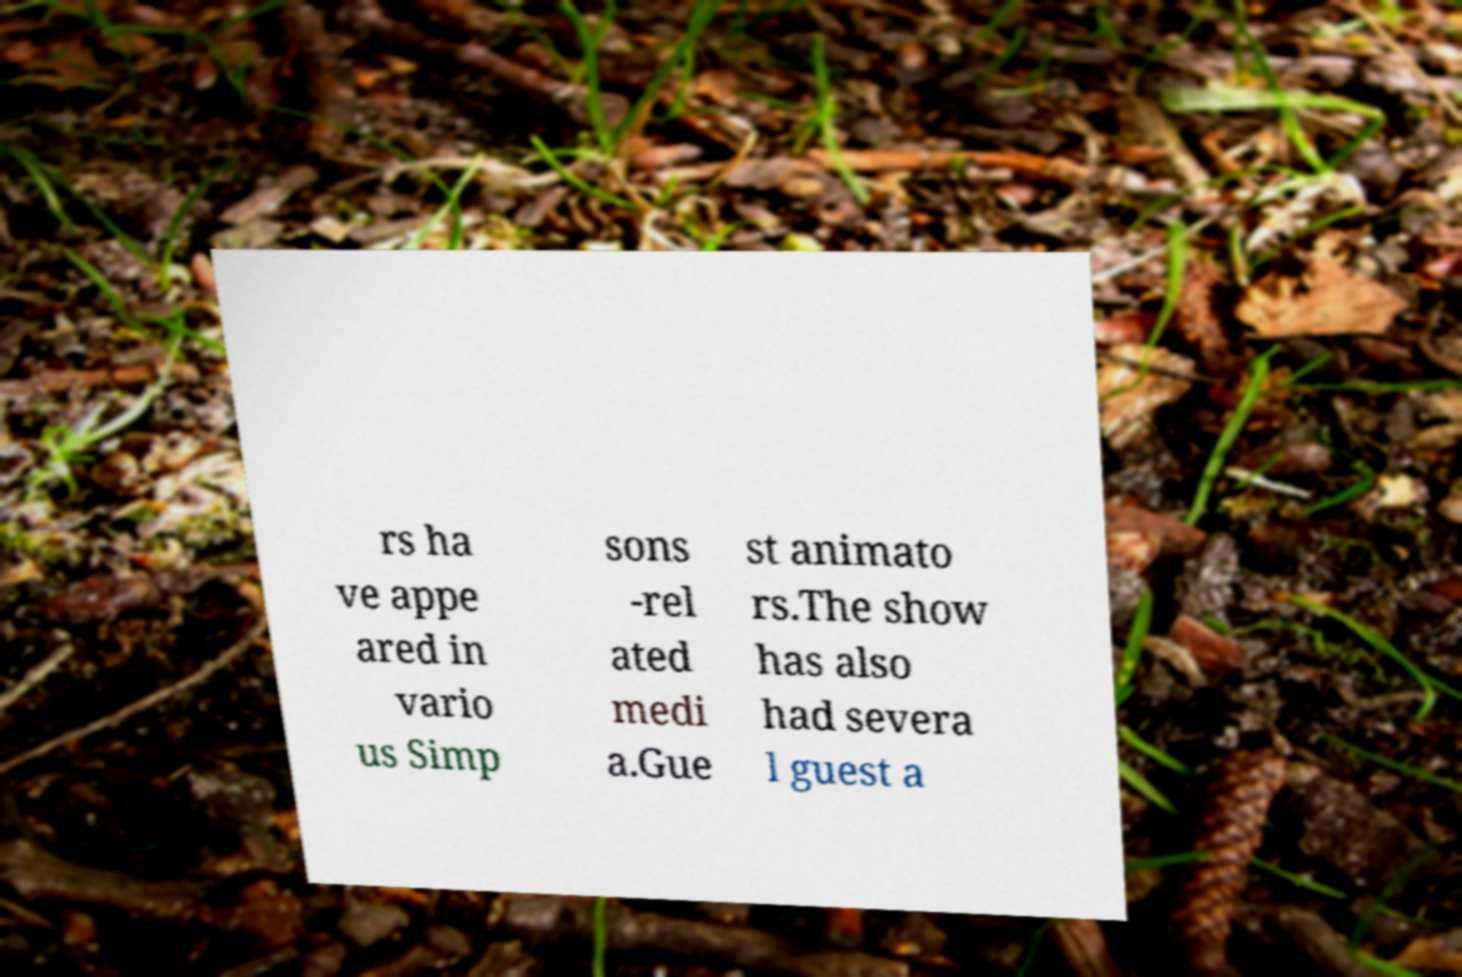What messages or text are displayed in this image? I need them in a readable, typed format. rs ha ve appe ared in vario us Simp sons -rel ated medi a.Gue st animato rs.The show has also had severa l guest a 